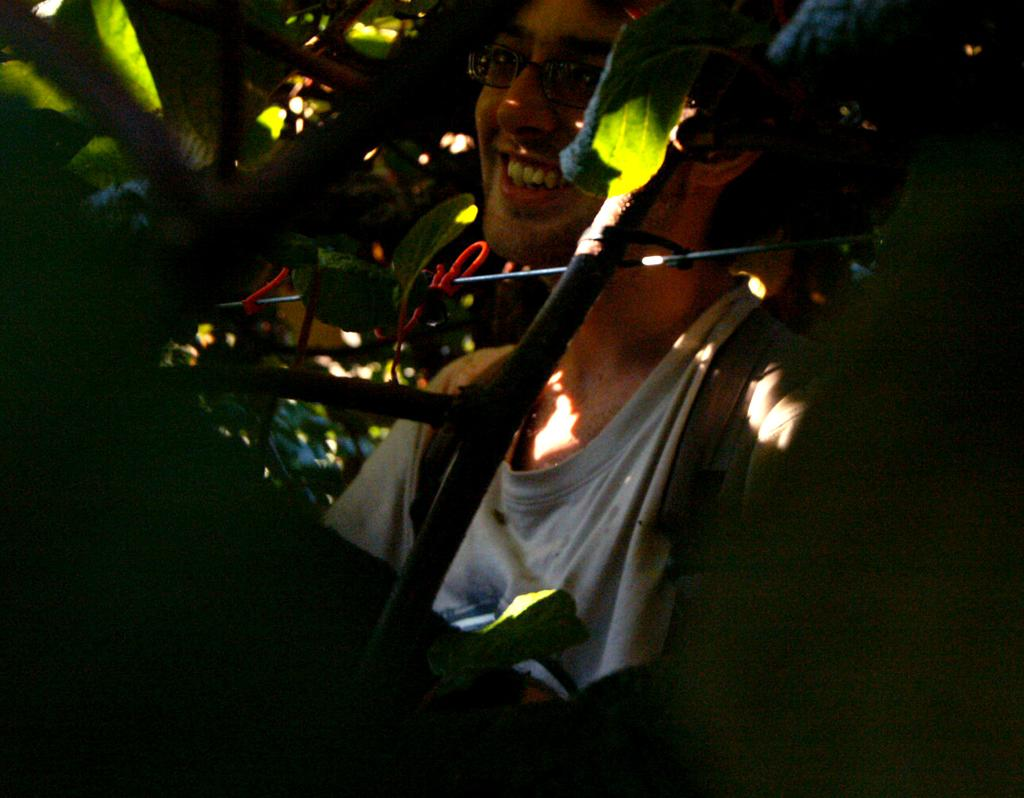Who is present in the image? There is a man in the image. What is the man wearing on his upper body? The man is wearing a t-shirt. What accessory is the man wearing on his face? The man is wearing spectacles. Where is the man situated in relation to the plants? The man is sitting near plants. What is the condition of the bottom left corner of the image? The bottom left corner of the image appears to be dark. What type of force can be seen pushing the ground in the image? There is no force pushing the ground in the image; it is a static scene with a man sitting near plants. What is the man's voice like in the image? The image is a still photograph, so there is no sound or voice present. 